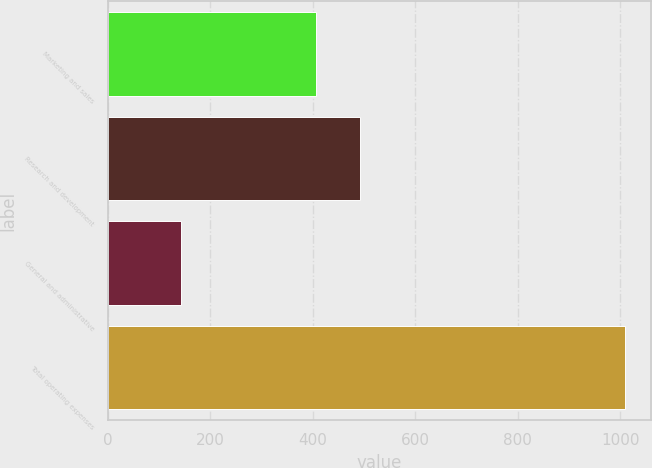Convert chart to OTSL. <chart><loc_0><loc_0><loc_500><loc_500><bar_chart><fcel>Marketing and sales<fcel>Research and development<fcel>General and administrative<fcel>Total operating expenses<nl><fcel>405.6<fcel>492.17<fcel>143.3<fcel>1009<nl></chart> 